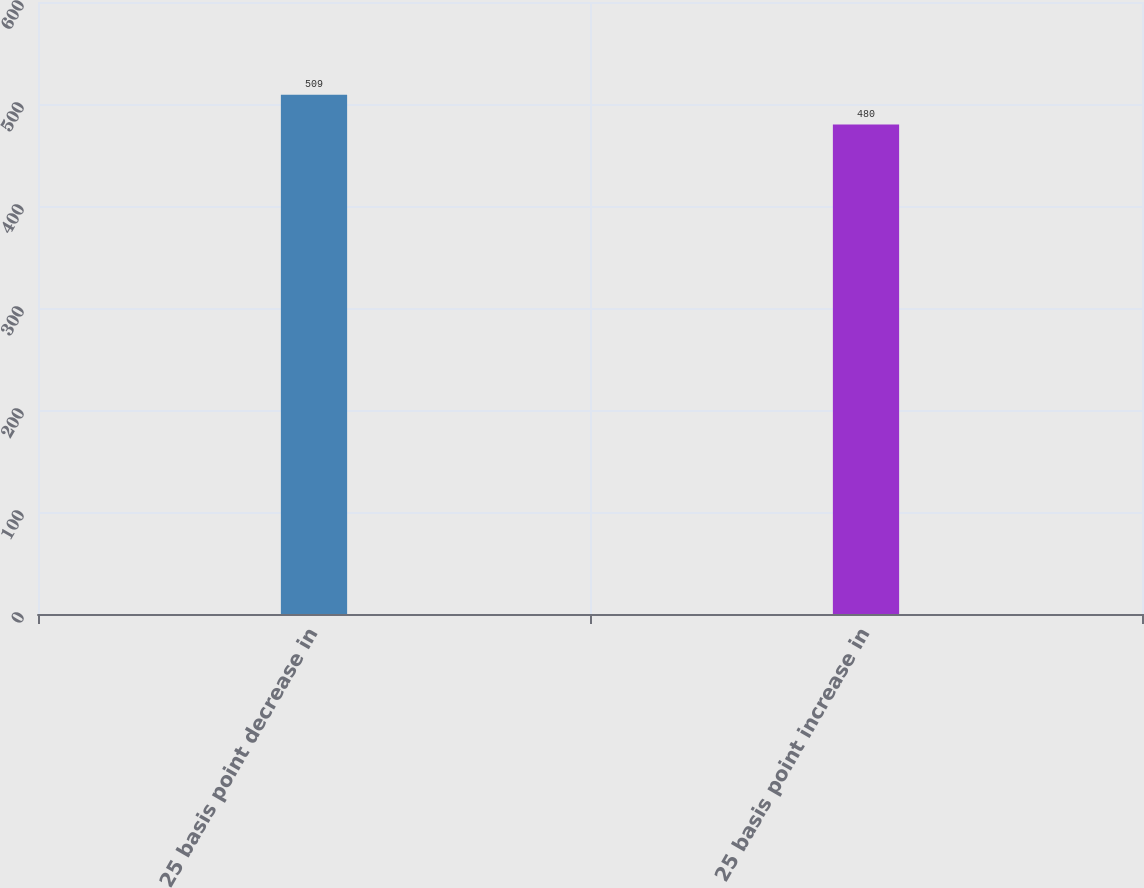<chart> <loc_0><loc_0><loc_500><loc_500><bar_chart><fcel>25 basis point decrease in<fcel>25 basis point increase in<nl><fcel>509<fcel>480<nl></chart> 